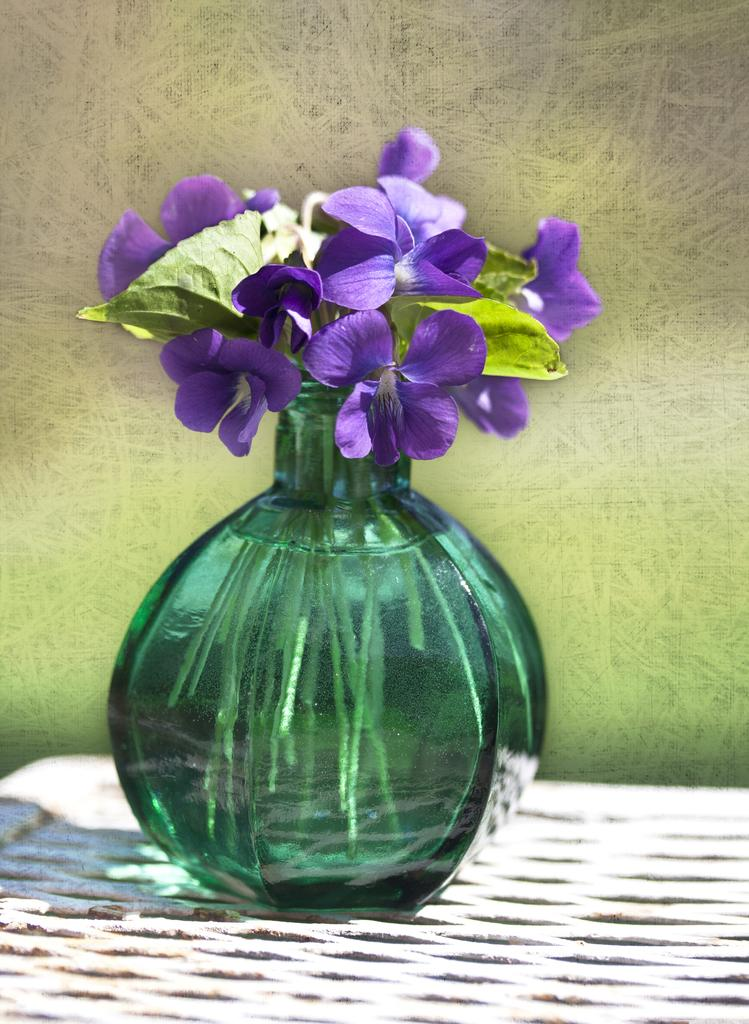What object is present in the image that can hold plants? There is a flower pot in the image. What is inside the flower pot? The flower pot contains water. What type of plant can be seen in the flower pot? There are flowers in the flower pot. What type of sail can be seen on the flowers in the image? There is no sail present in the image; it features a flower pot with flowers and water. What type of mint is growing in the flower pot? There is no mint plant present in the image; it contains flowers. 